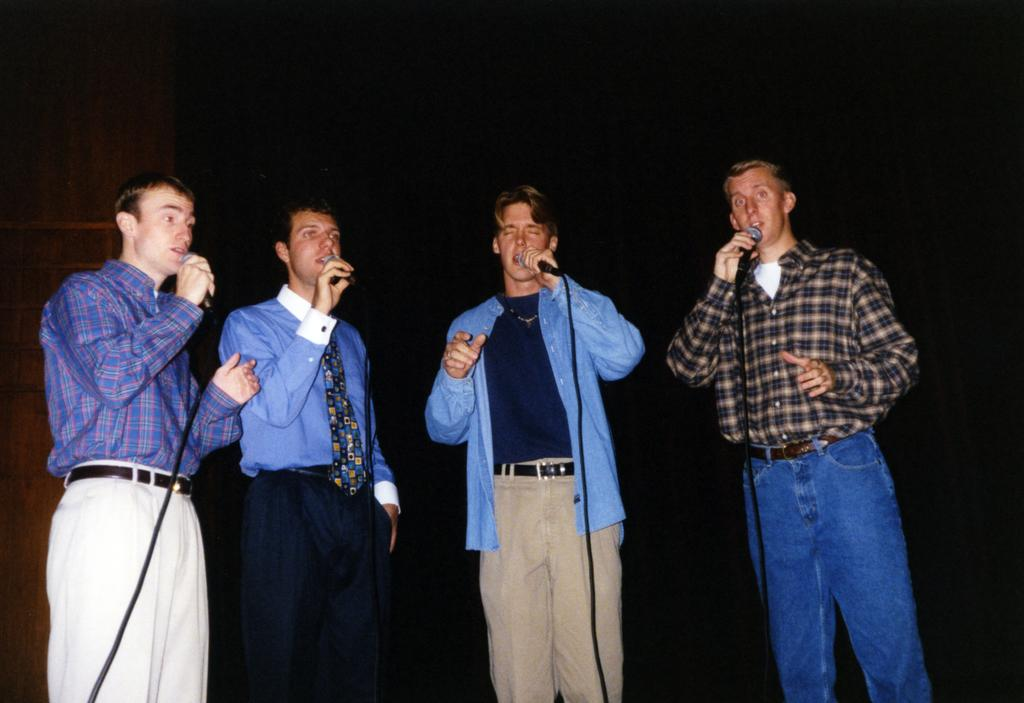How many people are in the image? There are people in the image, but the exact number is not specified. What are the people holding in the image? The people are holding microphones. What is the color of the background in the image? The background of the image is dark. What type of noise can be heard coming from the land in the image? There is no reference to any noise or land in the image, so it's not possible to determine what type of noise might be heard. 